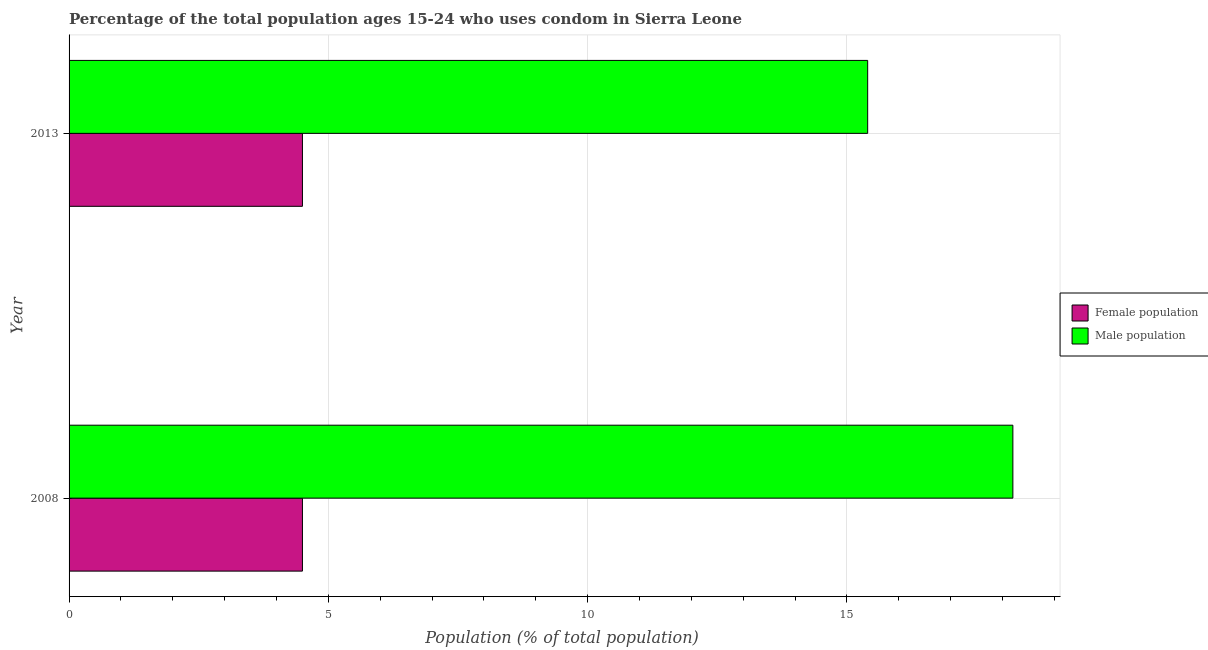Are the number of bars per tick equal to the number of legend labels?
Offer a very short reply. Yes. How many bars are there on the 1st tick from the top?
Provide a succinct answer. 2. How many bars are there on the 1st tick from the bottom?
Your answer should be very brief. 2. What is the label of the 1st group of bars from the top?
Keep it short and to the point. 2013. In which year was the female population maximum?
Offer a terse response. 2008. In which year was the male population minimum?
Offer a terse response. 2013. What is the total male population in the graph?
Offer a terse response. 33.6. What is the difference between the female population in 2008 and that in 2013?
Make the answer very short. 0. In the year 2013, what is the difference between the male population and female population?
Offer a very short reply. 10.9. What is the ratio of the female population in 2008 to that in 2013?
Make the answer very short. 1. In how many years, is the female population greater than the average female population taken over all years?
Offer a terse response. 0. What does the 2nd bar from the top in 2013 represents?
Keep it short and to the point. Female population. What does the 1st bar from the bottom in 2013 represents?
Your response must be concise. Female population. How many bars are there?
Your answer should be compact. 4. Are all the bars in the graph horizontal?
Your answer should be very brief. Yes. Are the values on the major ticks of X-axis written in scientific E-notation?
Offer a very short reply. No. Does the graph contain grids?
Your answer should be compact. Yes. How are the legend labels stacked?
Provide a short and direct response. Vertical. What is the title of the graph?
Offer a very short reply. Percentage of the total population ages 15-24 who uses condom in Sierra Leone. Does "Imports" appear as one of the legend labels in the graph?
Ensure brevity in your answer.  No. What is the label or title of the X-axis?
Give a very brief answer. Population (% of total population) . What is the label or title of the Y-axis?
Ensure brevity in your answer.  Year. What is the Population (% of total population)  of Female population in 2008?
Your response must be concise. 4.5. What is the Population (% of total population)  in Female population in 2013?
Offer a terse response. 4.5. Across all years, what is the minimum Population (% of total population)  of Female population?
Your response must be concise. 4.5. What is the total Population (% of total population)  of Female population in the graph?
Offer a terse response. 9. What is the total Population (% of total population)  in Male population in the graph?
Offer a terse response. 33.6. What is the difference between the Population (% of total population)  of Male population in 2008 and that in 2013?
Make the answer very short. 2.8. What is the difference between the Population (% of total population)  of Female population in 2008 and the Population (% of total population)  of Male population in 2013?
Give a very brief answer. -10.9. What is the average Population (% of total population)  of Female population per year?
Your answer should be very brief. 4.5. In the year 2008, what is the difference between the Population (% of total population)  in Female population and Population (% of total population)  in Male population?
Make the answer very short. -13.7. In the year 2013, what is the difference between the Population (% of total population)  of Female population and Population (% of total population)  of Male population?
Your answer should be compact. -10.9. What is the ratio of the Population (% of total population)  in Female population in 2008 to that in 2013?
Provide a succinct answer. 1. What is the ratio of the Population (% of total population)  of Male population in 2008 to that in 2013?
Offer a terse response. 1.18. What is the difference between the highest and the lowest Population (% of total population)  of Male population?
Provide a short and direct response. 2.8. 